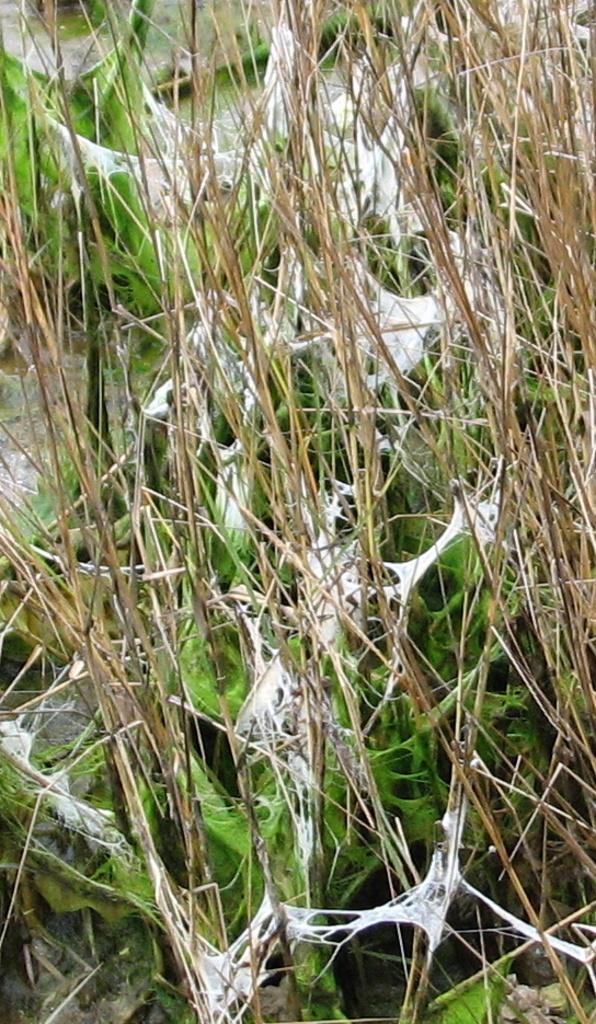Describe this image in one or two sentences. In this image, we can see some grass. We can also see some fungus. 